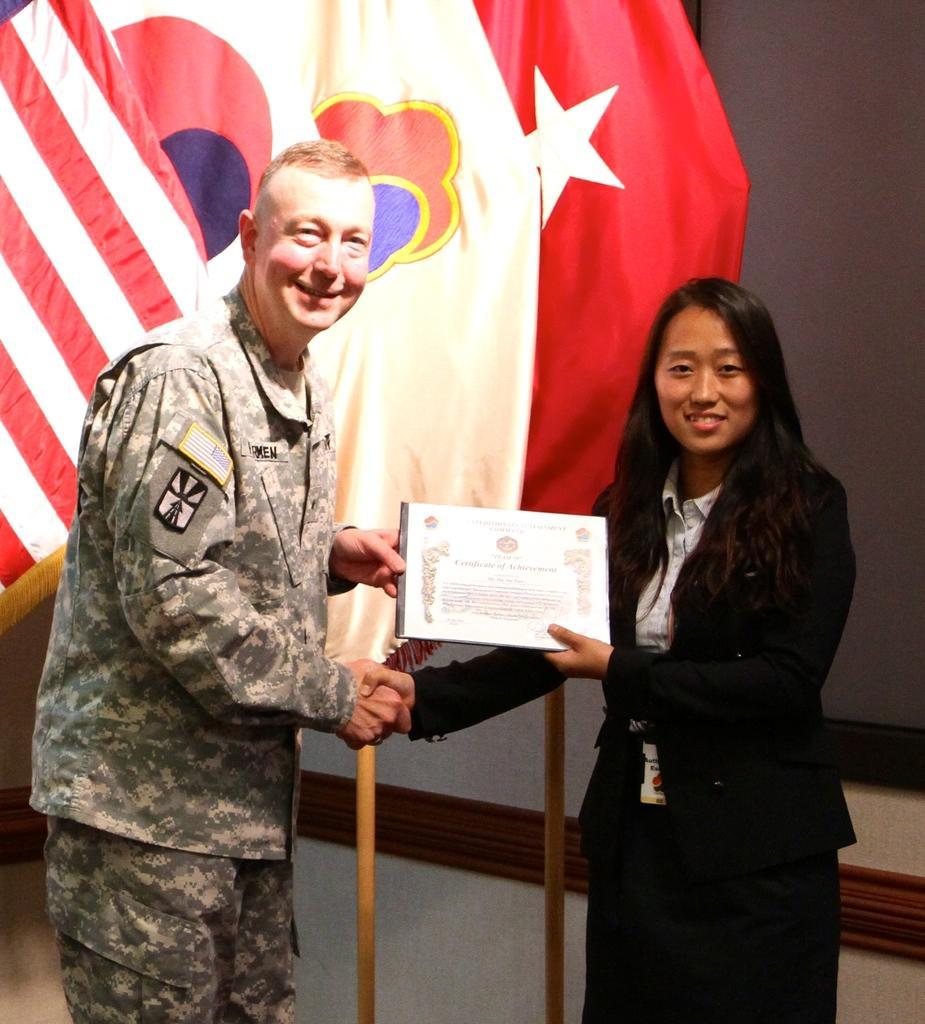Could you give a brief overview of what you see in this image? In the picture we can see a man and a woman, man is presenting and award to the woman and man is in army uniform and the woman is in black color blazer and they are smiling and behind them we can see some flags to the poles. 